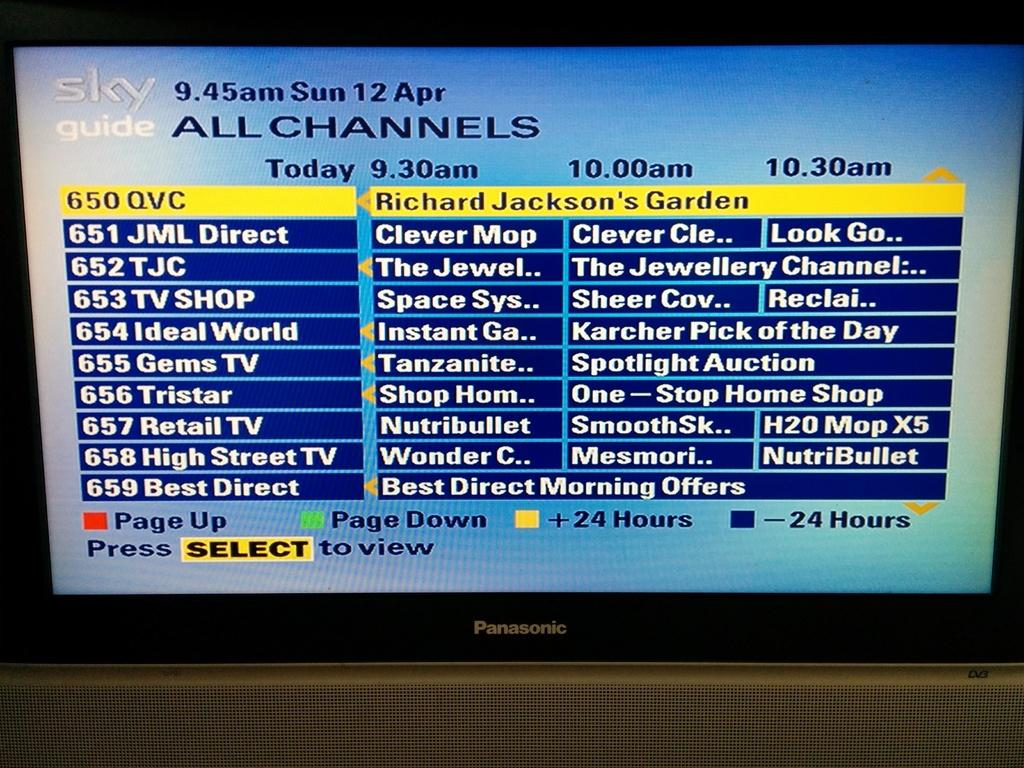<image>
Relay a brief, clear account of the picture shown. Panasonic television that is on the guide channels 